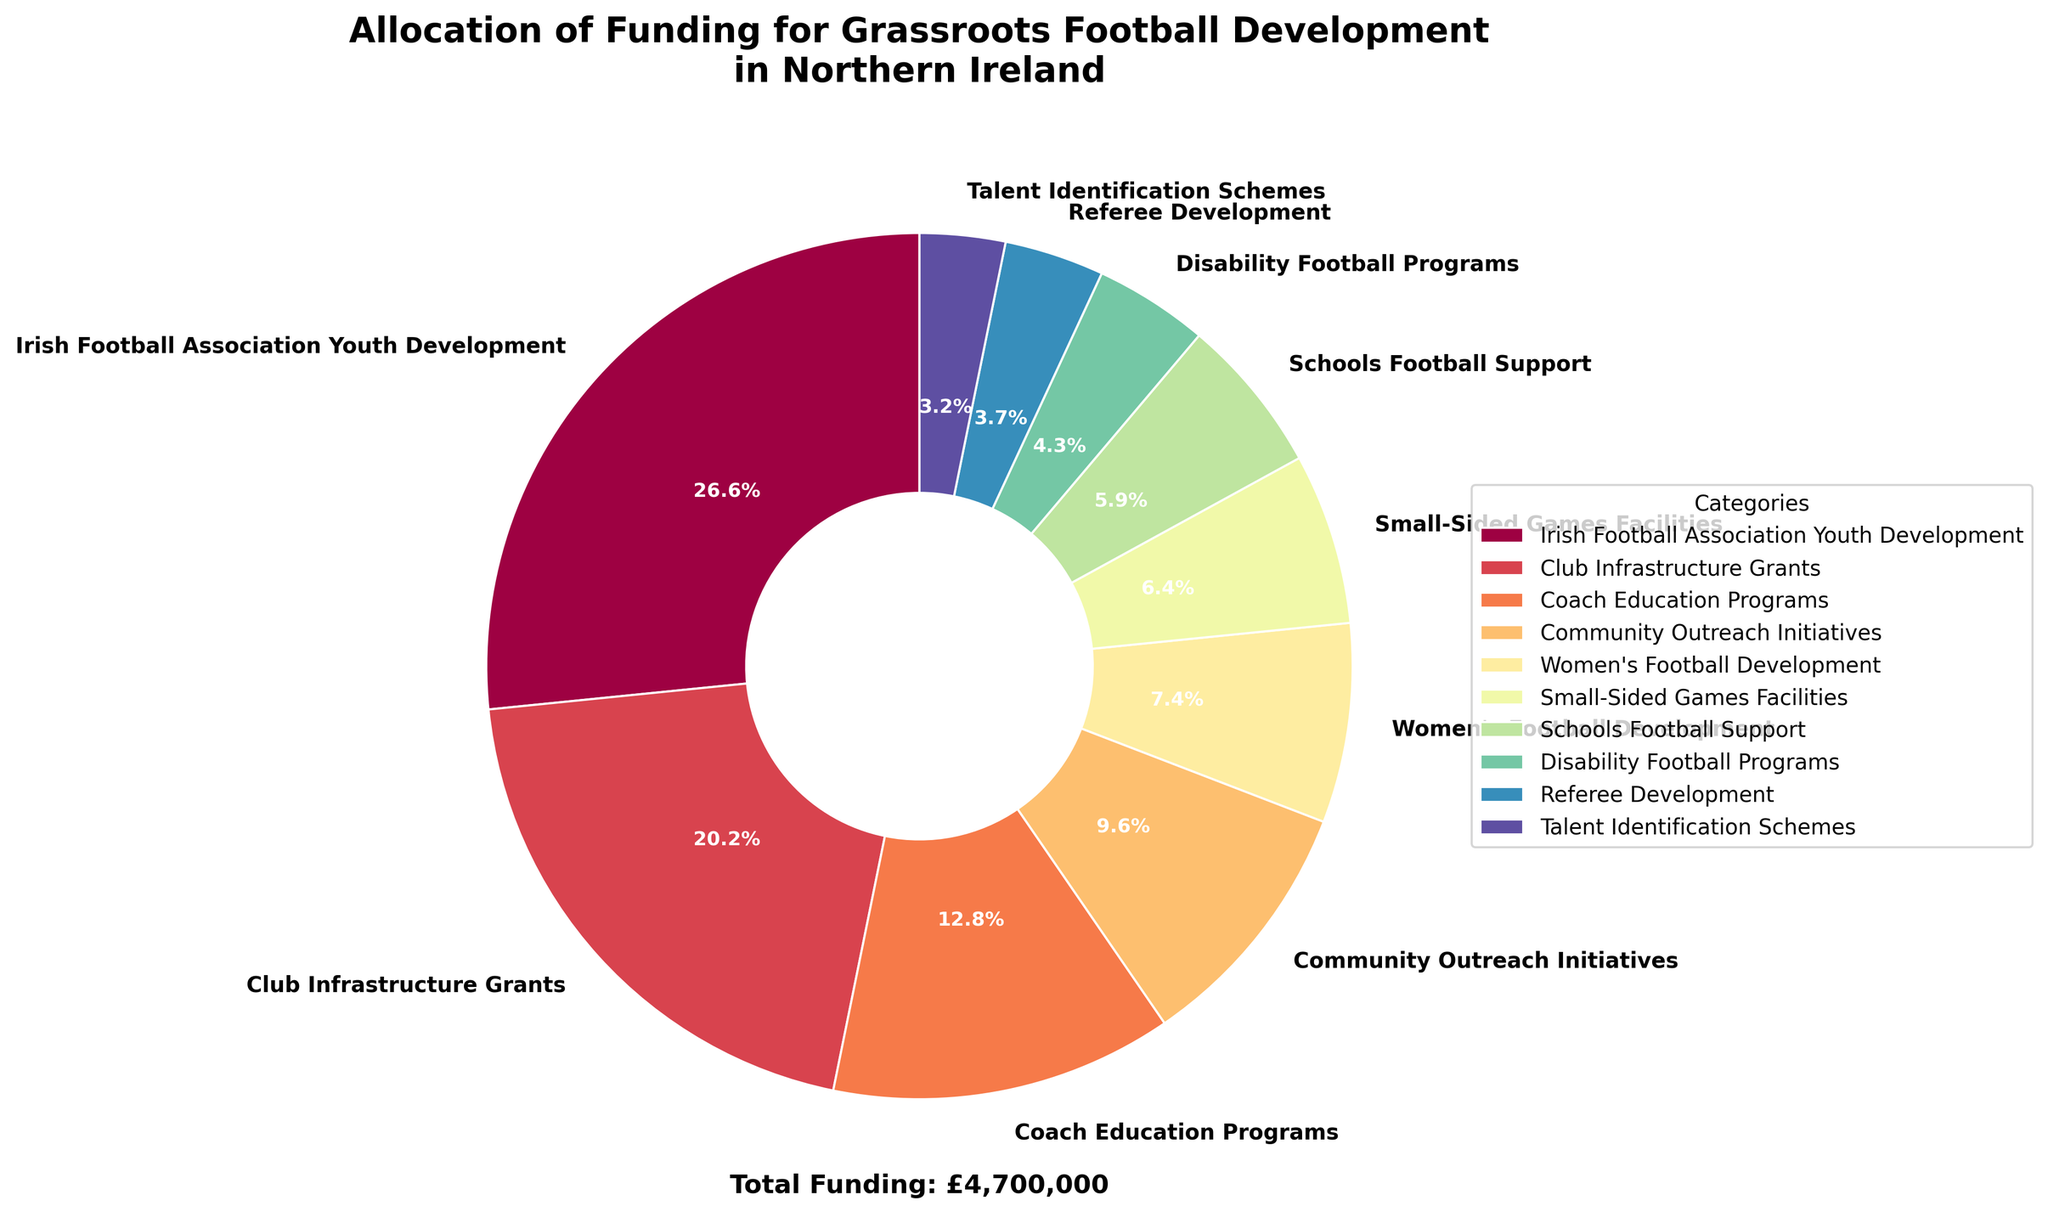What's the category with the largest funding allocation? First, observe the pie chart and identify the largest slice. Next, note the corresponding label, which represents the category with the largest funding allocation.
Answer: Irish Football Association Youth Development What is the total funding allocation for Women's Football Development and Schools Football Support combined? Identify the label and funding amounts for Women's Football Development (£350,000) and Schools Football Support (£275,000). Then, sum these amounts: £350,000 + £275,000 = £625,000.
Answer: £625,000 Which category receives less funding: Coach Education Programs or Community Outreach Initiatives? Look at the pie chart and compare the slices for Coach Education Programs and Community Outreach Initiatives. Coach Education Programs has a larger slice (and funding amount: £600,000) compared to Community Outreach Initiatives (£450,000). Therefore, Community Outreach Initiatives receives less funding.
Answer: Community Outreach Initiatives What percentage of the total funding goes to Club Infrastructure Grants? Find the label and funding amount for Club Infrastructure Grants on the pie chart (£950,000). Calculate the total funding amount (£4,500,000). Then, divide the Club Infrastructure Grants amount by the total and multiply by 100 to get the percentage: (£950,000 / £4,500,000) * 100 ≈ 21.1%.
Answer: 21.1% How much more funding does Irish Football Association Youth Development receive compared to Referee Development? Identify the funding amounts for Irish Football Association Youth Development (£1,250,000) and Referee Development (£175,000). Subtract the latter from the former: £1,250,000 - £175,000 = £1,075,000.
Answer: £1,075,000 If the funding for Disability Football Programs were to double, what would its new percentage be of the total funding? First, determine the funding for Disability Football Programs (£200,000). Doubling it would be £200,000 * 2 = £400,000. Add the additional £200,000 to the original total funding (£4,500,000 + £200,000 = £4,700,000). Calculate the new percentage: (£400,000 / £4,700,000) * 100 ≈ 8.5%.
Answer: 8.5% Which category receives the smallest funding allocation? Observe the smallest slice in the pie chart and note its corresponding label, which identifies the category with the smallest funding allocation.
Answer: Talent Identification Schemes What is the difference in funding allocation between the top two highest-funded categories? Identify the top two highest-funded categories: Irish Football Association Youth Development (£1,250,000) and Club Infrastructure Grants (£950,000). Then, subtract the second-highest from the highest: £1,250,000 - £950,000 = £300,000.
Answer: £300,000 